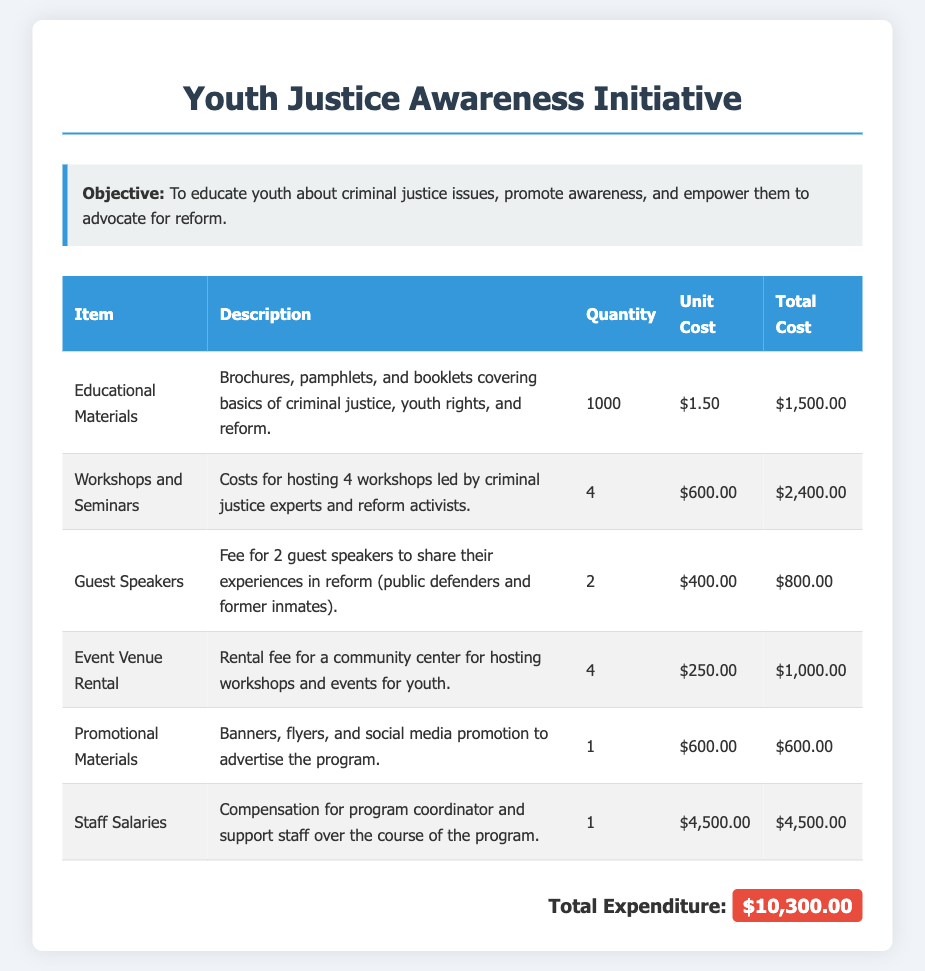What is the total expenditure? The total expenditure is the sum of all itemized costs listed in the document.
Answer: $10,300.00 How many workshops were hosted? The document indicates that 4 workshops were hosted as part of the initiative.
Answer: 4 What is the unit cost of educational materials? The unit cost for educational materials is specified in the document.
Answer: $1.50 What is included in the promotional materials? The description for promotional materials lists different types of advertising items.
Answer: Banners, flyers, and social media promotion How many guest speakers were paid? The document states that fees were provided for 2 guest speakers.
Answer: 2 What was the rental fee for the event venue? The rental fee per event is detailed in the expenditures section.
Answer: $250.00 What is the role of the staff salaries in the budget? The description explains the compensation provided for certain staff involved in the program.
Answer: Compensation for program coordinator and support staff How much did the guest speakers cost in total? The document provides the total cost associated with hiring the guest speakers.
Answer: $800.00 Why were workshops necessary according to the document? The objective discusses educating youth about criminal justice issues as a key reason for hosting workshops.
Answer: To educate youth about criminal justice issues 